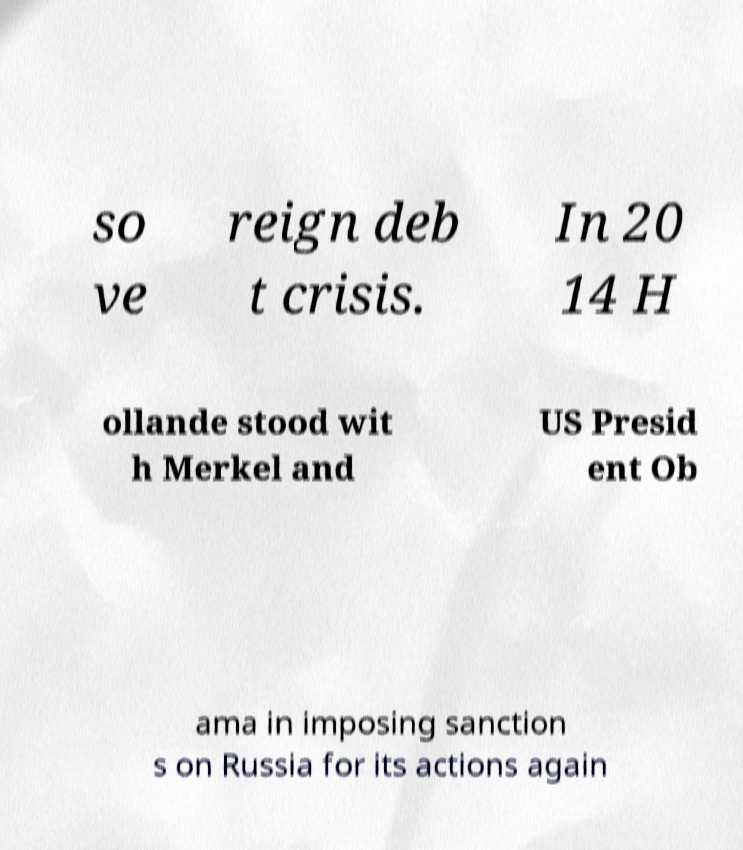What messages or text are displayed in this image? I need them in a readable, typed format. so ve reign deb t crisis. In 20 14 H ollande stood wit h Merkel and US Presid ent Ob ama in imposing sanction s on Russia for its actions again 